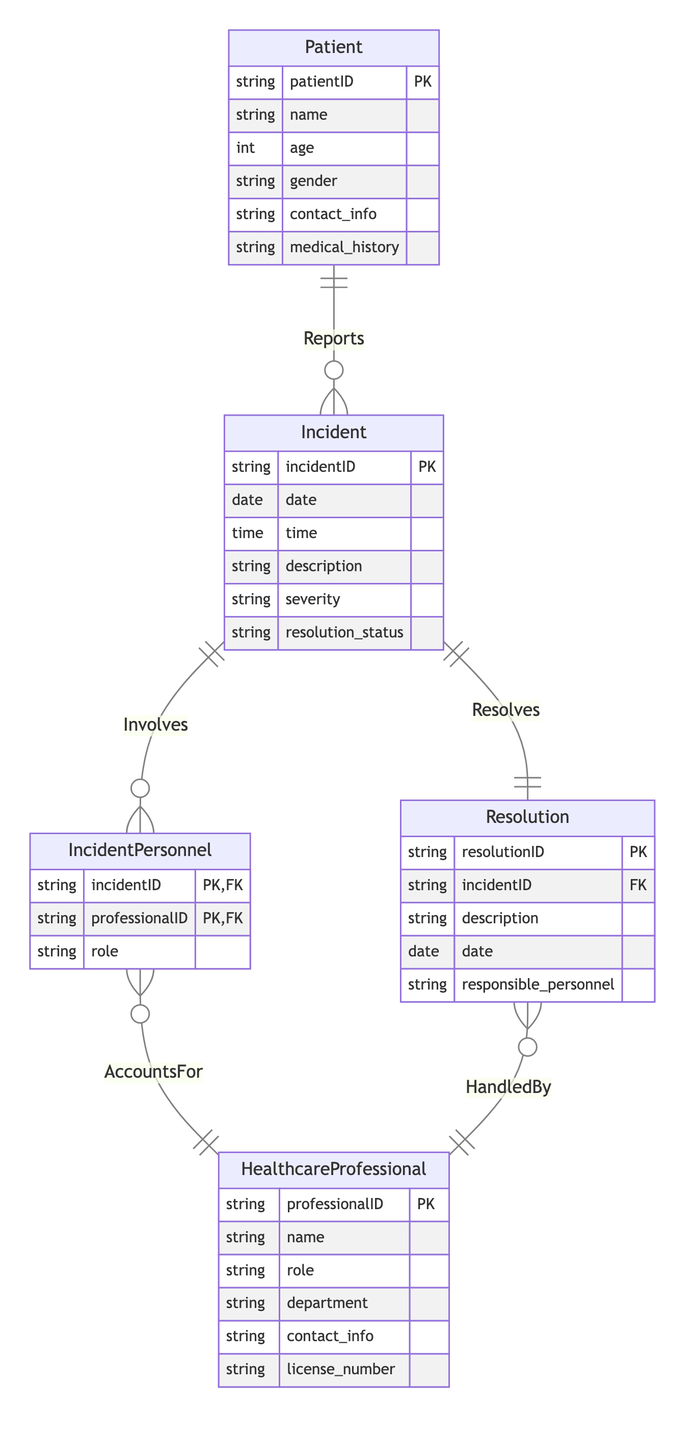What is the primary key of the Incident entity? The primary key for the Incident entity is labeled distinctly in the diagram, specifically denoted as "incidentID," which uniquely identifies each incident in the system.
Answer: incidentID How many entities are involved in the diagram? The diagram lists five entities: Patient, Incident, HealthcareProfessional, Resolution, and IncidentPersonnel. Counting these gives the total number of entities.
Answer: five What relationship type connects Patient and Incident? The relationship type connecting Patient and Incident is labeled "Reports," indicating that a patient can report multiple incidents. This is identified by the relationship notation in the diagram.
Answer: Reports What is the cardinality of the relationship between IncidentPersonnel and HealthcareProfessional? The relationship between IncidentPersonnel and HealthcareProfessional is noted as "N:1," indicating that multiple incident personnel can be associated with a single healthcare professional. This cardinality is derived from the relationship line in the diagram.
Answer: N:1 Which entity has a foreign key referencing Incident? The entity that contains a foreign key referencing Incident is the Resolution entity, as indicated by the diagram where "incidentID" is marked as a foreign key in the Resolution entity attributes.
Answer: Resolution What is the purpose of the Resolution entity in the diagram? The Resolution entity captures information related to the outcomes of incidents, detailing the resolution process and linking back to the particular incident it addresses, as indicated by its connection in the diagram.
Answer: To capture incident outcomes Which relationship indicates who resolves the incident? The relationship that indicates who resolves the incident is labeled "Resolves," connecting the Resolution entity to the Incident entity. This is shown in the relationship name and connects these two entities.
Answer: Resolves How many roles can a HealthcareProfessional have in this system? A HealthcareProfessional can have multiple roles as the diagram indicates that N IncidentPersonnel can be associated with one HealthcareProfessional, suggesting multiple personnel may list the same healthcare professional in different roles.
Answer: N What indicates the nature of the relationship between Incident and IncidentPersonnel? The nature of the relationship between Incident and IncidentPersonnel is indicated by the label "Involves," demonstrating that a single incident can involve multiple personnel, noted by the cardinality of "1:N."
Answer: Involves 